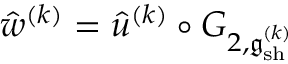<formula> <loc_0><loc_0><loc_500><loc_500>\hat { w } ^ { ( k ) } = \hat { u } ^ { ( k ) } \circ G _ { 2 , \mathfrak { g } _ { s h } ^ { ( k ) } }</formula> 